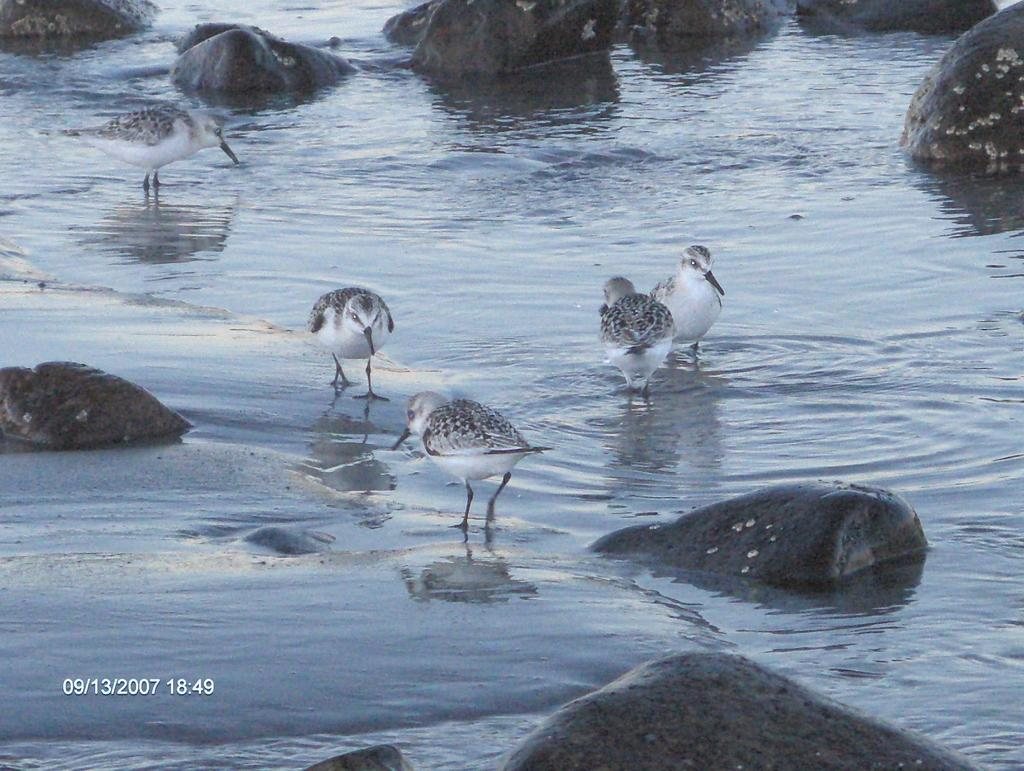What is located in the center of the image? There is water, stones, and birds in the center of the image. What is the color scheme of the image? The image is in black and white color. What can be found on the left side of the image? There is some text on the left side of the image. What is the name of the son mentioned in the text on the left side of the image? There is no mention of a son or any text in the image, as it only features water, stones, birds, and the black and white color scheme. 